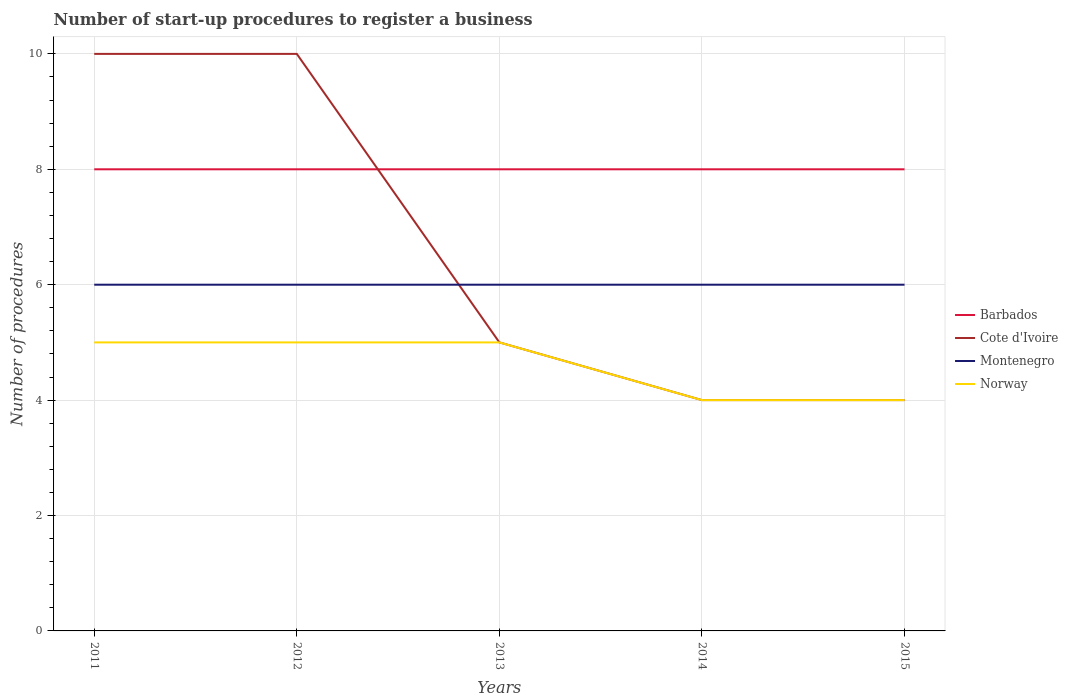Is the number of lines equal to the number of legend labels?
Provide a succinct answer. Yes. What is the total number of procedures required to register a business in Montenegro in the graph?
Give a very brief answer. 0. What is the difference between the highest and the second highest number of procedures required to register a business in Montenegro?
Offer a terse response. 0. How many lines are there?
Ensure brevity in your answer.  4. How many years are there in the graph?
Keep it short and to the point. 5. What is the difference between two consecutive major ticks on the Y-axis?
Your response must be concise. 2. What is the title of the graph?
Your response must be concise. Number of start-up procedures to register a business. What is the label or title of the Y-axis?
Offer a very short reply. Number of procedures. What is the Number of procedures in Barbados in 2011?
Give a very brief answer. 8. What is the Number of procedures of Cote d'Ivoire in 2011?
Your response must be concise. 10. What is the Number of procedures of Norway in 2011?
Your answer should be very brief. 5. What is the Number of procedures in Barbados in 2012?
Your answer should be compact. 8. What is the Number of procedures of Cote d'Ivoire in 2012?
Keep it short and to the point. 10. What is the Number of procedures of Norway in 2012?
Provide a succinct answer. 5. What is the Number of procedures in Barbados in 2013?
Your answer should be very brief. 8. What is the Number of procedures of Cote d'Ivoire in 2013?
Your answer should be very brief. 5. What is the Number of procedures in Norway in 2013?
Your answer should be compact. 5. What is the Number of procedures in Cote d'Ivoire in 2014?
Provide a short and direct response. 4. What is the Number of procedures of Cote d'Ivoire in 2015?
Offer a terse response. 4. Across all years, what is the maximum Number of procedures in Barbados?
Provide a short and direct response. 8. Across all years, what is the maximum Number of procedures of Cote d'Ivoire?
Give a very brief answer. 10. Across all years, what is the minimum Number of procedures in Barbados?
Provide a short and direct response. 8. What is the total Number of procedures of Barbados in the graph?
Ensure brevity in your answer.  40. What is the total Number of procedures in Cote d'Ivoire in the graph?
Your response must be concise. 33. What is the total Number of procedures in Montenegro in the graph?
Give a very brief answer. 30. What is the difference between the Number of procedures of Barbados in 2011 and that in 2012?
Give a very brief answer. 0. What is the difference between the Number of procedures of Cote d'Ivoire in 2011 and that in 2012?
Offer a very short reply. 0. What is the difference between the Number of procedures in Montenegro in 2011 and that in 2012?
Ensure brevity in your answer.  0. What is the difference between the Number of procedures in Barbados in 2011 and that in 2013?
Give a very brief answer. 0. What is the difference between the Number of procedures in Norway in 2011 and that in 2013?
Your answer should be compact. 0. What is the difference between the Number of procedures in Cote d'Ivoire in 2011 and that in 2014?
Give a very brief answer. 6. What is the difference between the Number of procedures in Montenegro in 2011 and that in 2014?
Offer a very short reply. 0. What is the difference between the Number of procedures of Norway in 2011 and that in 2014?
Your response must be concise. 1. What is the difference between the Number of procedures of Montenegro in 2011 and that in 2015?
Your answer should be very brief. 0. What is the difference between the Number of procedures in Cote d'Ivoire in 2012 and that in 2013?
Offer a very short reply. 5. What is the difference between the Number of procedures of Norway in 2012 and that in 2013?
Offer a terse response. 0. What is the difference between the Number of procedures in Cote d'Ivoire in 2012 and that in 2015?
Your response must be concise. 6. What is the difference between the Number of procedures in Montenegro in 2012 and that in 2015?
Offer a very short reply. 0. What is the difference between the Number of procedures in Norway in 2012 and that in 2015?
Provide a short and direct response. 1. What is the difference between the Number of procedures in Cote d'Ivoire in 2013 and that in 2014?
Provide a succinct answer. 1. What is the difference between the Number of procedures of Montenegro in 2013 and that in 2014?
Ensure brevity in your answer.  0. What is the difference between the Number of procedures in Norway in 2013 and that in 2015?
Your answer should be very brief. 1. What is the difference between the Number of procedures in Montenegro in 2014 and that in 2015?
Give a very brief answer. 0. What is the difference between the Number of procedures of Barbados in 2011 and the Number of procedures of Montenegro in 2012?
Provide a short and direct response. 2. What is the difference between the Number of procedures in Barbados in 2011 and the Number of procedures in Norway in 2012?
Offer a terse response. 3. What is the difference between the Number of procedures in Cote d'Ivoire in 2011 and the Number of procedures in Montenegro in 2012?
Offer a terse response. 4. What is the difference between the Number of procedures in Barbados in 2011 and the Number of procedures in Cote d'Ivoire in 2013?
Your answer should be very brief. 3. What is the difference between the Number of procedures of Barbados in 2011 and the Number of procedures of Montenegro in 2013?
Your answer should be compact. 2. What is the difference between the Number of procedures in Barbados in 2011 and the Number of procedures in Norway in 2013?
Your answer should be compact. 3. What is the difference between the Number of procedures of Cote d'Ivoire in 2011 and the Number of procedures of Norway in 2013?
Offer a very short reply. 5. What is the difference between the Number of procedures in Barbados in 2011 and the Number of procedures in Montenegro in 2014?
Offer a terse response. 2. What is the difference between the Number of procedures of Barbados in 2011 and the Number of procedures of Norway in 2014?
Offer a very short reply. 4. What is the difference between the Number of procedures in Cote d'Ivoire in 2011 and the Number of procedures in Norway in 2014?
Provide a succinct answer. 6. What is the difference between the Number of procedures of Montenegro in 2011 and the Number of procedures of Norway in 2015?
Provide a succinct answer. 2. What is the difference between the Number of procedures in Barbados in 2012 and the Number of procedures in Cote d'Ivoire in 2013?
Make the answer very short. 3. What is the difference between the Number of procedures of Cote d'Ivoire in 2012 and the Number of procedures of Norway in 2013?
Your answer should be very brief. 5. What is the difference between the Number of procedures in Barbados in 2012 and the Number of procedures in Norway in 2014?
Offer a very short reply. 4. What is the difference between the Number of procedures in Cote d'Ivoire in 2012 and the Number of procedures in Montenegro in 2014?
Provide a succinct answer. 4. What is the difference between the Number of procedures in Barbados in 2012 and the Number of procedures in Norway in 2015?
Provide a short and direct response. 4. What is the difference between the Number of procedures of Cote d'Ivoire in 2012 and the Number of procedures of Montenegro in 2015?
Ensure brevity in your answer.  4. What is the difference between the Number of procedures in Cote d'Ivoire in 2012 and the Number of procedures in Norway in 2015?
Your answer should be very brief. 6. What is the difference between the Number of procedures of Barbados in 2013 and the Number of procedures of Norway in 2014?
Give a very brief answer. 4. What is the difference between the Number of procedures in Cote d'Ivoire in 2013 and the Number of procedures in Montenegro in 2014?
Offer a very short reply. -1. What is the difference between the Number of procedures of Montenegro in 2013 and the Number of procedures of Norway in 2014?
Your answer should be very brief. 2. What is the difference between the Number of procedures of Barbados in 2013 and the Number of procedures of Montenegro in 2015?
Your answer should be very brief. 2. What is the difference between the Number of procedures of Cote d'Ivoire in 2013 and the Number of procedures of Montenegro in 2015?
Make the answer very short. -1. What is the difference between the Number of procedures of Cote d'Ivoire in 2013 and the Number of procedures of Norway in 2015?
Your response must be concise. 1. What is the difference between the Number of procedures in Montenegro in 2013 and the Number of procedures in Norway in 2015?
Your response must be concise. 2. What is the difference between the Number of procedures of Barbados in 2014 and the Number of procedures of Cote d'Ivoire in 2015?
Offer a very short reply. 4. What is the difference between the Number of procedures in Barbados in 2014 and the Number of procedures in Montenegro in 2015?
Make the answer very short. 2. What is the difference between the Number of procedures of Barbados in 2014 and the Number of procedures of Norway in 2015?
Keep it short and to the point. 4. What is the difference between the Number of procedures of Cote d'Ivoire in 2014 and the Number of procedures of Montenegro in 2015?
Make the answer very short. -2. What is the difference between the Number of procedures of Cote d'Ivoire in 2014 and the Number of procedures of Norway in 2015?
Your response must be concise. 0. What is the difference between the Number of procedures of Montenegro in 2014 and the Number of procedures of Norway in 2015?
Keep it short and to the point. 2. What is the average Number of procedures in Cote d'Ivoire per year?
Provide a short and direct response. 6.6. What is the average Number of procedures in Montenegro per year?
Offer a very short reply. 6. What is the average Number of procedures of Norway per year?
Your answer should be very brief. 4.6. In the year 2011, what is the difference between the Number of procedures of Barbados and Number of procedures of Cote d'Ivoire?
Your answer should be compact. -2. In the year 2011, what is the difference between the Number of procedures in Barbados and Number of procedures in Montenegro?
Provide a short and direct response. 2. In the year 2011, what is the difference between the Number of procedures in Cote d'Ivoire and Number of procedures in Montenegro?
Provide a short and direct response. 4. In the year 2011, what is the difference between the Number of procedures of Montenegro and Number of procedures of Norway?
Keep it short and to the point. 1. In the year 2012, what is the difference between the Number of procedures in Barbados and Number of procedures in Cote d'Ivoire?
Provide a succinct answer. -2. In the year 2012, what is the difference between the Number of procedures in Barbados and Number of procedures in Montenegro?
Provide a succinct answer. 2. In the year 2012, what is the difference between the Number of procedures of Barbados and Number of procedures of Norway?
Keep it short and to the point. 3. In the year 2012, what is the difference between the Number of procedures of Montenegro and Number of procedures of Norway?
Provide a short and direct response. 1. In the year 2013, what is the difference between the Number of procedures in Barbados and Number of procedures in Montenegro?
Give a very brief answer. 2. In the year 2013, what is the difference between the Number of procedures in Cote d'Ivoire and Number of procedures in Montenegro?
Ensure brevity in your answer.  -1. In the year 2013, what is the difference between the Number of procedures of Cote d'Ivoire and Number of procedures of Norway?
Provide a succinct answer. 0. In the year 2013, what is the difference between the Number of procedures in Montenegro and Number of procedures in Norway?
Give a very brief answer. 1. In the year 2014, what is the difference between the Number of procedures of Barbados and Number of procedures of Cote d'Ivoire?
Keep it short and to the point. 4. In the year 2014, what is the difference between the Number of procedures in Barbados and Number of procedures in Norway?
Give a very brief answer. 4. In the year 2014, what is the difference between the Number of procedures of Cote d'Ivoire and Number of procedures of Norway?
Make the answer very short. 0. In the year 2015, what is the difference between the Number of procedures in Barbados and Number of procedures in Cote d'Ivoire?
Make the answer very short. 4. In the year 2015, what is the difference between the Number of procedures of Barbados and Number of procedures of Norway?
Keep it short and to the point. 4. In the year 2015, what is the difference between the Number of procedures in Cote d'Ivoire and Number of procedures in Montenegro?
Offer a terse response. -2. In the year 2015, what is the difference between the Number of procedures in Cote d'Ivoire and Number of procedures in Norway?
Give a very brief answer. 0. In the year 2015, what is the difference between the Number of procedures of Montenegro and Number of procedures of Norway?
Your answer should be very brief. 2. What is the ratio of the Number of procedures in Cote d'Ivoire in 2011 to that in 2012?
Make the answer very short. 1. What is the ratio of the Number of procedures of Montenegro in 2011 to that in 2012?
Provide a succinct answer. 1. What is the ratio of the Number of procedures of Barbados in 2011 to that in 2013?
Provide a short and direct response. 1. What is the ratio of the Number of procedures of Cote d'Ivoire in 2011 to that in 2013?
Give a very brief answer. 2. What is the ratio of the Number of procedures of Norway in 2011 to that in 2013?
Offer a very short reply. 1. What is the ratio of the Number of procedures in Cote d'Ivoire in 2011 to that in 2014?
Offer a very short reply. 2.5. What is the ratio of the Number of procedures of Montenegro in 2011 to that in 2014?
Offer a very short reply. 1. What is the ratio of the Number of procedures of Barbados in 2011 to that in 2015?
Offer a terse response. 1. What is the ratio of the Number of procedures of Cote d'Ivoire in 2011 to that in 2015?
Your answer should be very brief. 2.5. What is the ratio of the Number of procedures of Barbados in 2012 to that in 2013?
Make the answer very short. 1. What is the ratio of the Number of procedures in Montenegro in 2012 to that in 2013?
Offer a terse response. 1. What is the ratio of the Number of procedures in Norway in 2012 to that in 2013?
Keep it short and to the point. 1. What is the ratio of the Number of procedures of Cote d'Ivoire in 2012 to that in 2014?
Ensure brevity in your answer.  2.5. What is the ratio of the Number of procedures of Barbados in 2012 to that in 2015?
Offer a very short reply. 1. What is the ratio of the Number of procedures of Cote d'Ivoire in 2012 to that in 2015?
Ensure brevity in your answer.  2.5. What is the ratio of the Number of procedures in Montenegro in 2012 to that in 2015?
Offer a very short reply. 1. What is the ratio of the Number of procedures in Barbados in 2013 to that in 2014?
Keep it short and to the point. 1. What is the ratio of the Number of procedures of Cote d'Ivoire in 2013 to that in 2014?
Provide a short and direct response. 1.25. What is the ratio of the Number of procedures of Montenegro in 2013 to that in 2014?
Make the answer very short. 1. What is the ratio of the Number of procedures of Barbados in 2013 to that in 2015?
Keep it short and to the point. 1. What is the ratio of the Number of procedures of Cote d'Ivoire in 2013 to that in 2015?
Keep it short and to the point. 1.25. What is the ratio of the Number of procedures of Norway in 2013 to that in 2015?
Your answer should be very brief. 1.25. What is the ratio of the Number of procedures in Cote d'Ivoire in 2014 to that in 2015?
Offer a terse response. 1. What is the ratio of the Number of procedures of Montenegro in 2014 to that in 2015?
Your answer should be very brief. 1. What is the ratio of the Number of procedures of Norway in 2014 to that in 2015?
Your answer should be very brief. 1. What is the difference between the highest and the second highest Number of procedures of Barbados?
Offer a very short reply. 0. What is the difference between the highest and the second highest Number of procedures of Cote d'Ivoire?
Offer a terse response. 0. What is the difference between the highest and the second highest Number of procedures in Montenegro?
Give a very brief answer. 0. What is the difference between the highest and the second highest Number of procedures in Norway?
Make the answer very short. 0. What is the difference between the highest and the lowest Number of procedures of Barbados?
Your response must be concise. 0. What is the difference between the highest and the lowest Number of procedures in Norway?
Ensure brevity in your answer.  1. 